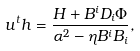<formula> <loc_0><loc_0><loc_500><loc_500>u ^ { t } h = \frac { H + B ^ { i } D _ { i } \Phi } { \alpha ^ { 2 } - \eta B ^ { i } B _ { i } } ,</formula> 